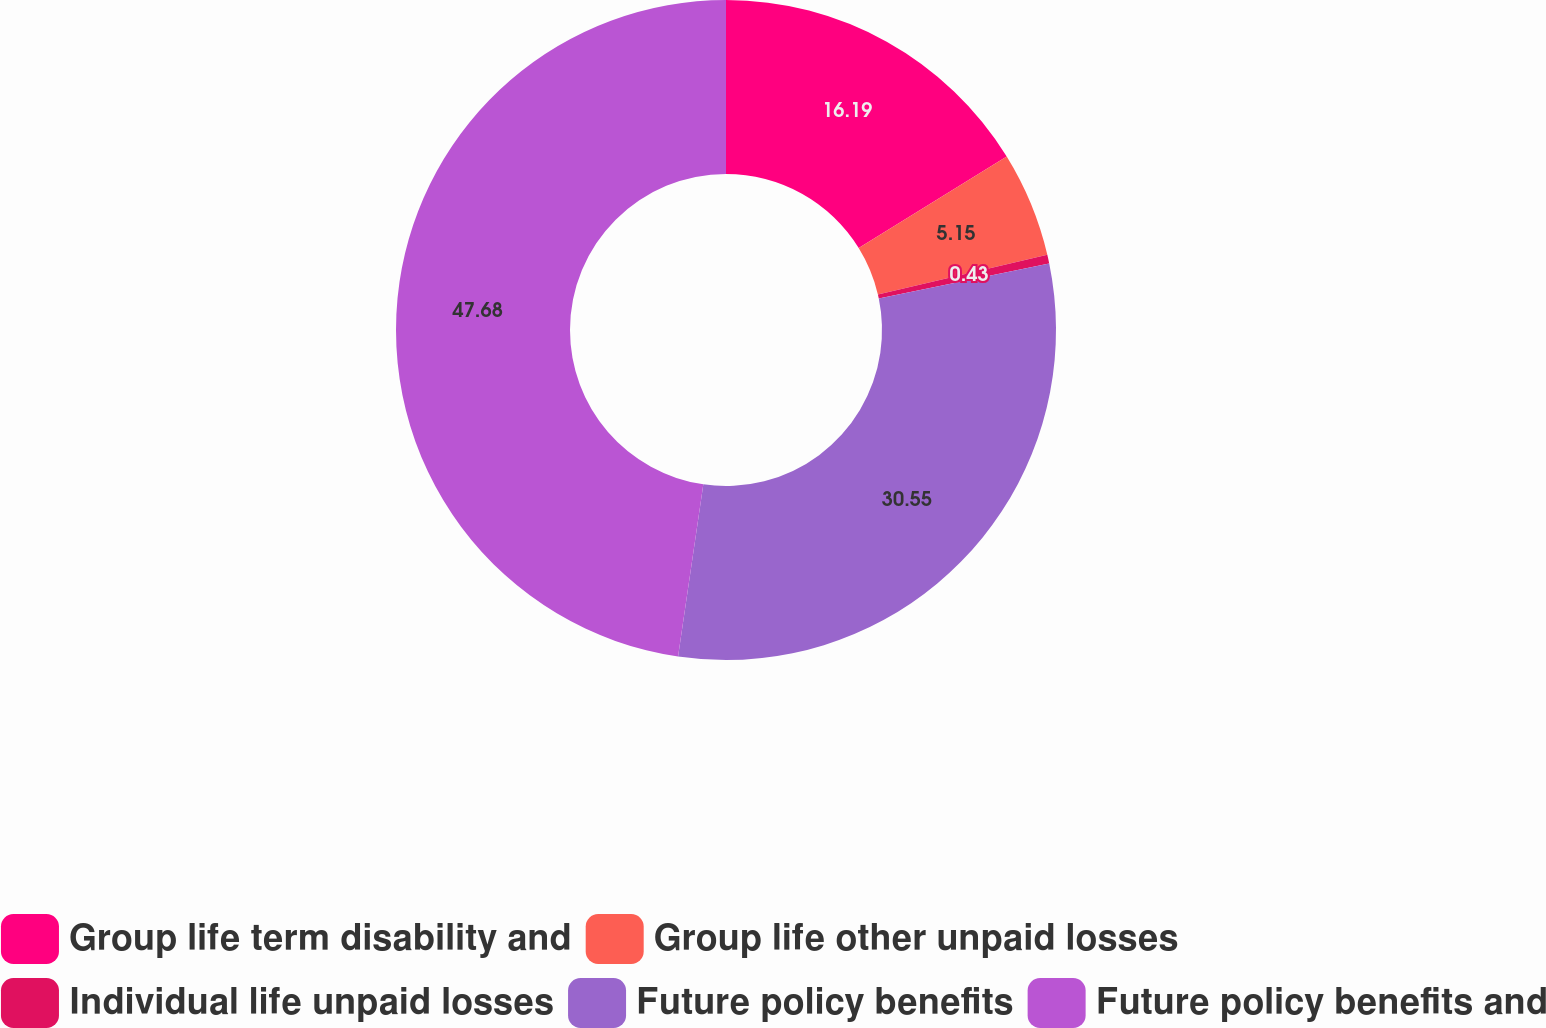<chart> <loc_0><loc_0><loc_500><loc_500><pie_chart><fcel>Group life term disability and<fcel>Group life other unpaid losses<fcel>Individual life unpaid losses<fcel>Future policy benefits<fcel>Future policy benefits and<nl><fcel>16.19%<fcel>5.15%<fcel>0.43%<fcel>30.55%<fcel>47.68%<nl></chart> 